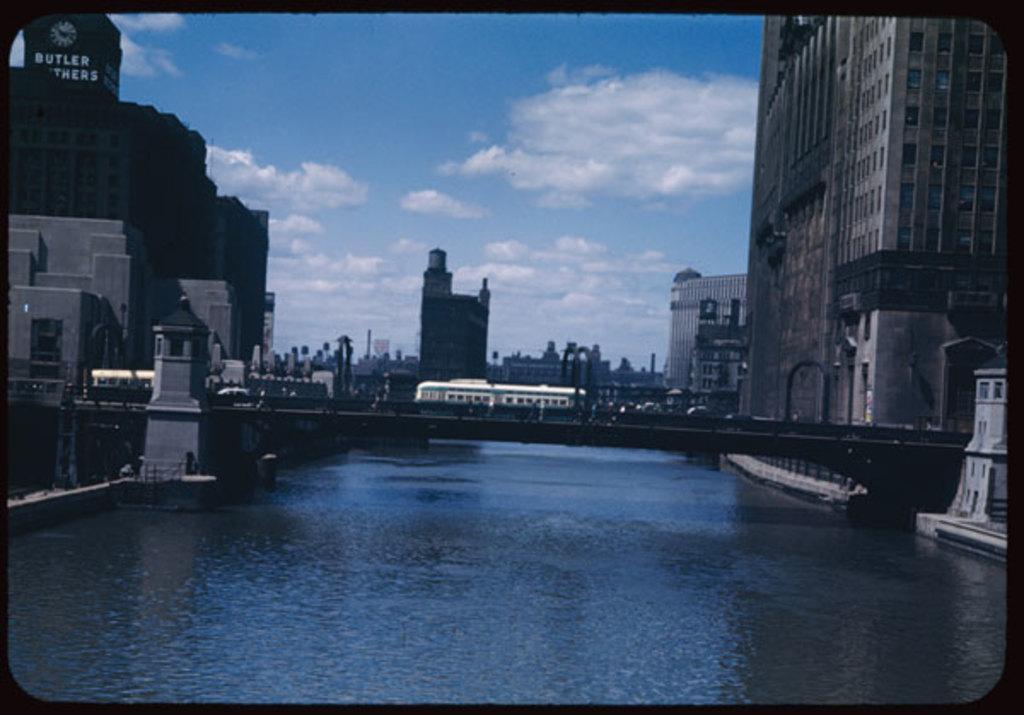How would you summarize this image in a sentence or two? In this image we can see an old photograph, in the photograph we can see there is a river flowing from the middle of the city, we can see the bridge and the buildings on the either side of the river, on the bridge there are a few vehicles passing. 